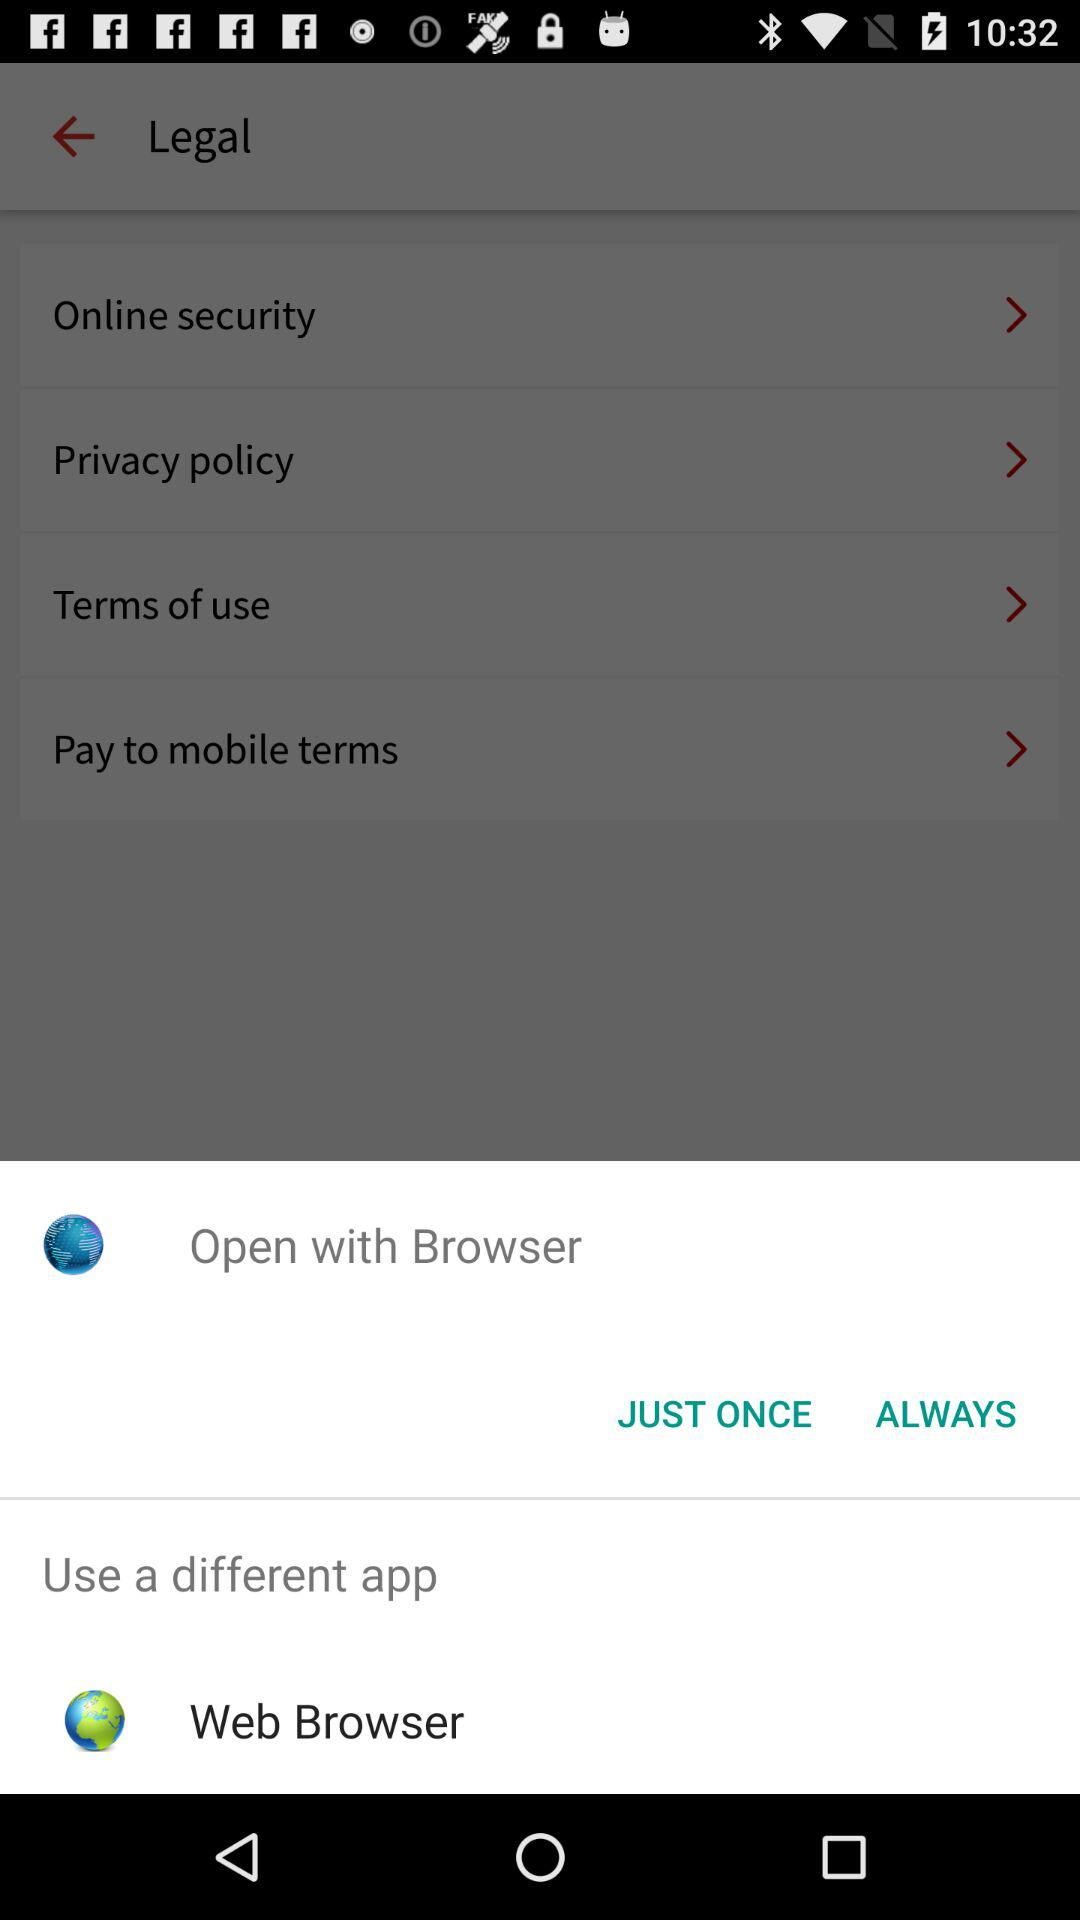How many legal terms are there?
Answer the question using a single word or phrase. 4 